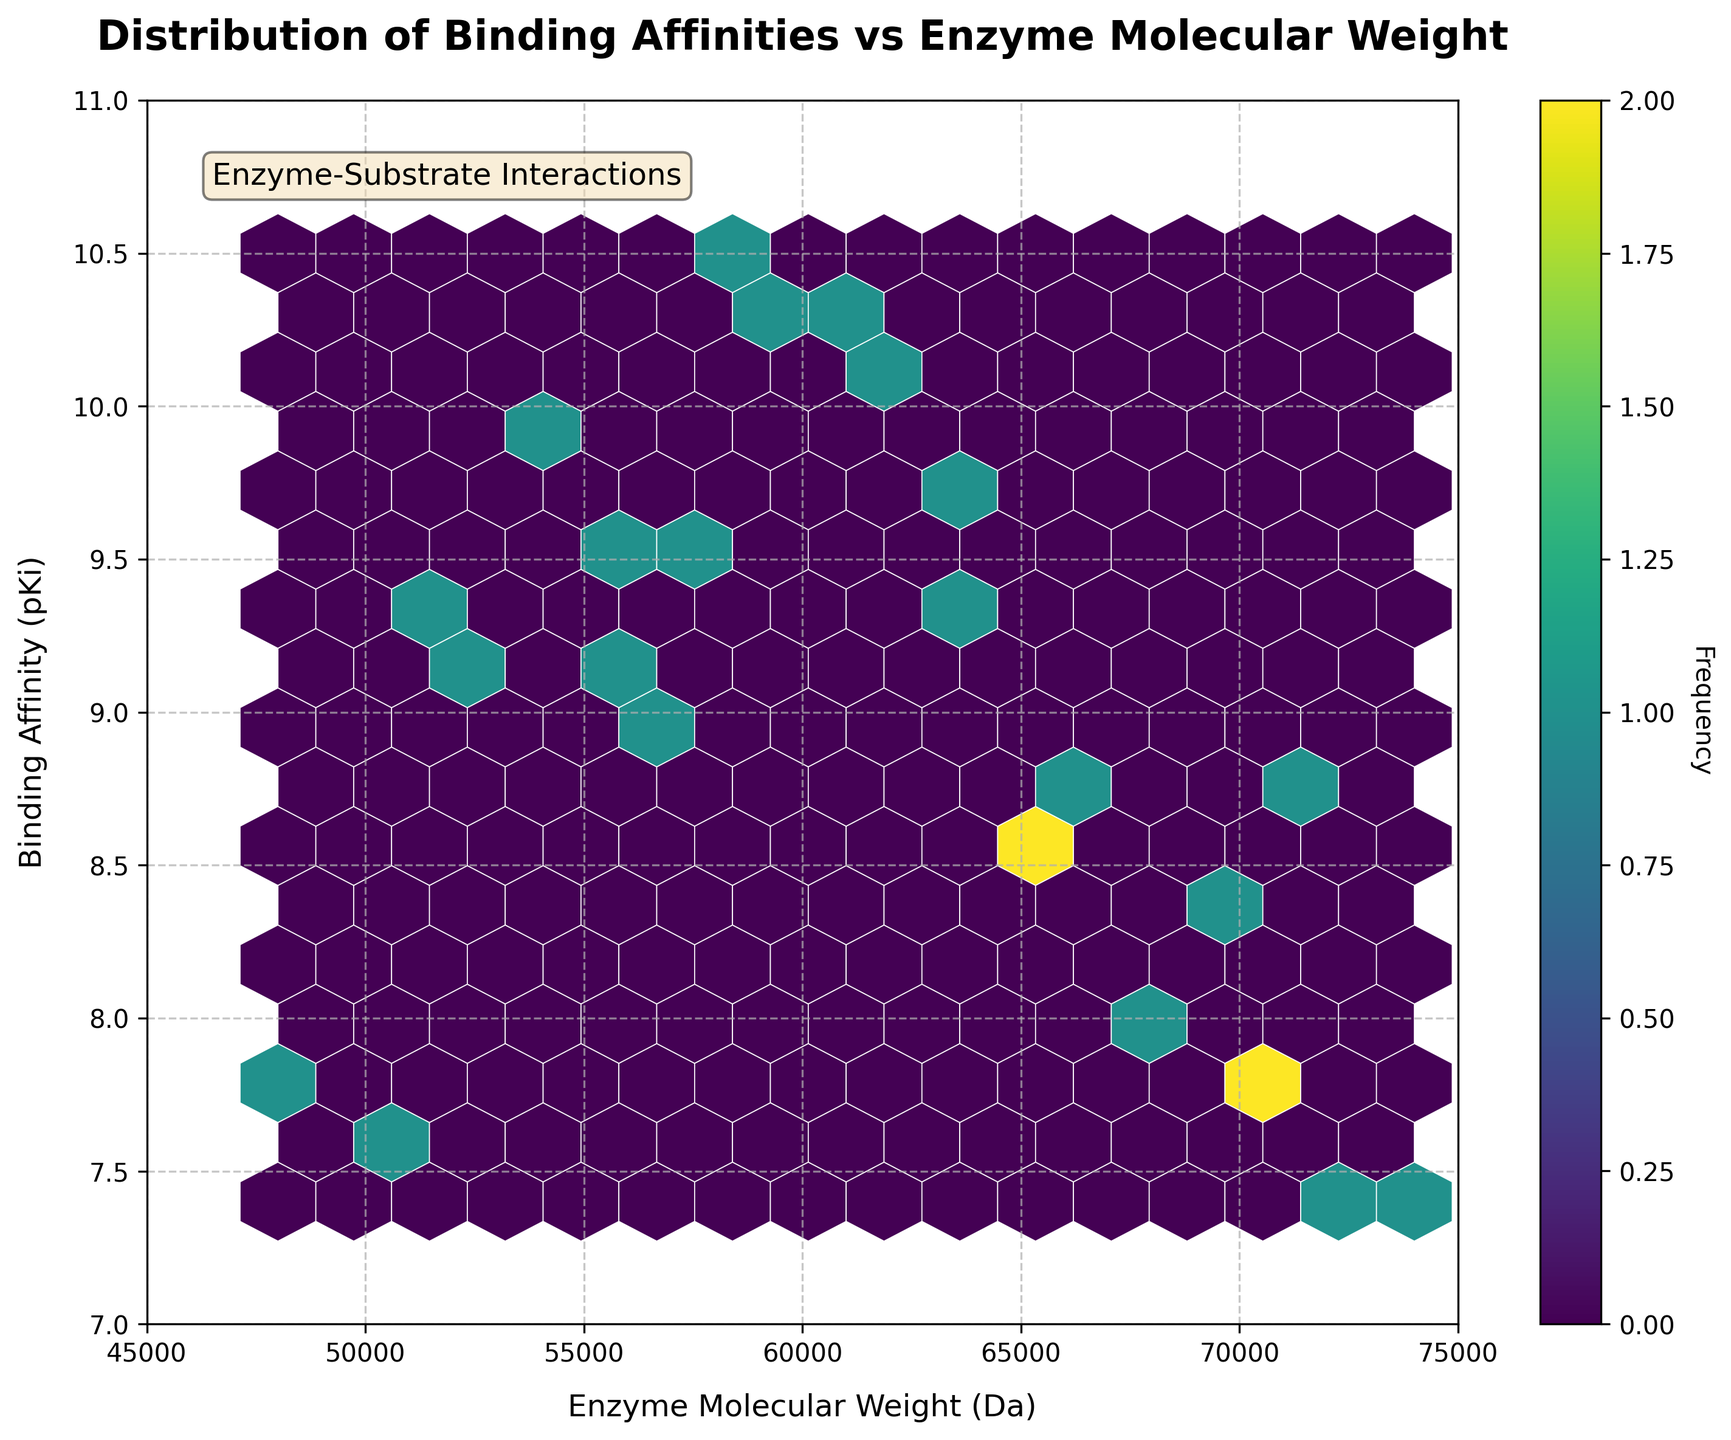How many hexagonal bins are present in the plot? Count the number of hexagonal bins displayed in the figure. This involves visually inspecting the plot and counting each unique hexagonal cell, which represents a bin. The total number you're left with is the number of hexagonal bins.
Answer: 15 What does the color of the hexagons represent? The color of each hexagon in the hexbin plot represents the frequency of enzyme-inhibitor pairs that fall within that particular bin. Darker hexagons indicate higher frequencies, while lighter hexagons indicate lower frequencies.
Answer: Frequency What are the axis labels of the hexbin plot? Look at the labels on the X-axis and Y-axis in the figure. The X-axis label is "Enzyme Molecular Weight (Da)," and the Y-axis label is "Binding Affinity (pKi)."
Answer: Enzyme Molecular Weight (Da), Binding Affinity (pKi) What is the title of the plot? The title of the plot is usually located at the top of the figure. In this case, it is "Distribution of Binding Affinities vs Enzyme Molecular Weight."
Answer: Distribution of Binding Affinities vs Enzyme Molecular Weight Which binding affinity (pKi) range has the highest enzyme molecular weights in the plot? Determine which range of binding affinity (pKi) values corresponds to the highest density of hexagons with high enzyme molecular weights. This can be visually evaluated by looking for the darkest-colored bins at high molecular weight positions on the plot.
Answer: 10-10.5 What do the axis limits in the plot indicate for Enzyme Molecular Weight and Binding Affinity? Examine the range of the X and Y axes. The X-axis ranges from 45000 to 75000 Da, indicating the span of molecular weights of the enzymes. The Y-axis ranges from 7 to 11, indicating the range of binding affinities (pKi).
Answer: 45000-75000 Da for Enzyme Molecular Weight, 7-11 for Binding Affinity Which range of Enzyme Molecular Weight has the highest frequency of binding affinities? Identify the range on the X-axis (Enzyme Molecular Weight) that encompasses the most densely colored hexagons. This shows where the majority of data points are clustered.
Answer: 60000-65000 Da Is there a visible correlation between Enzyme Molecular Weight and Binding Affinity? Observe the distribution of the hexagons. If there's a consistent pattern where higher molecular weights correspond to higher or lower binding affinities, this might suggest a correlation. In this plot, there seems to be a slight trend, but it's not strongly correlated.
Answer: Slight positive trend, but not strongly correlated How frequently are binding affinities (pKi) of 10.5 observed for any given molecular weight, based on the color intensity? Examine the color intensity of hexagons that align with a binding affinity (pKi) of 10.5. The color intensity indicates how frequently these values occur. The darker and more numerous the hexagons around 10.5, the more frequent these values are.
Answer: High frequency 